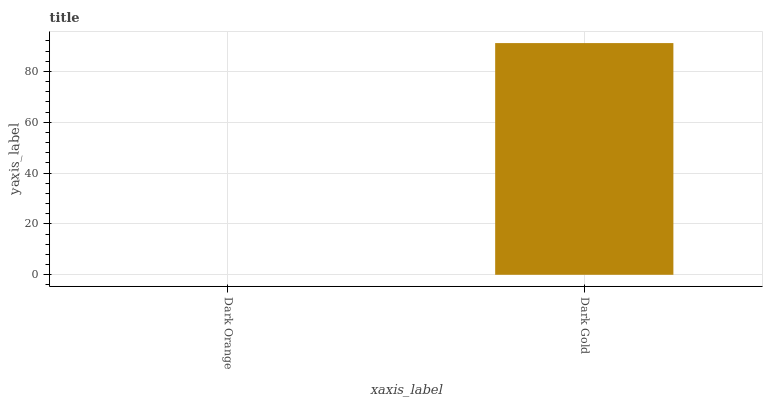Is Dark Orange the minimum?
Answer yes or no. Yes. Is Dark Gold the maximum?
Answer yes or no. Yes. Is Dark Gold the minimum?
Answer yes or no. No. Is Dark Gold greater than Dark Orange?
Answer yes or no. Yes. Is Dark Orange less than Dark Gold?
Answer yes or no. Yes. Is Dark Orange greater than Dark Gold?
Answer yes or no. No. Is Dark Gold less than Dark Orange?
Answer yes or no. No. Is Dark Gold the high median?
Answer yes or no. Yes. Is Dark Orange the low median?
Answer yes or no. Yes. Is Dark Orange the high median?
Answer yes or no. No. Is Dark Gold the low median?
Answer yes or no. No. 